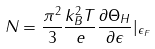Convert formula to latex. <formula><loc_0><loc_0><loc_500><loc_500>N = \frac { \pi ^ { 2 } } { 3 } \frac { k _ { B } ^ { 2 } T } { e } \frac { \partial \Theta _ { H } } { \partial \epsilon } | _ { \epsilon _ { F } }</formula> 